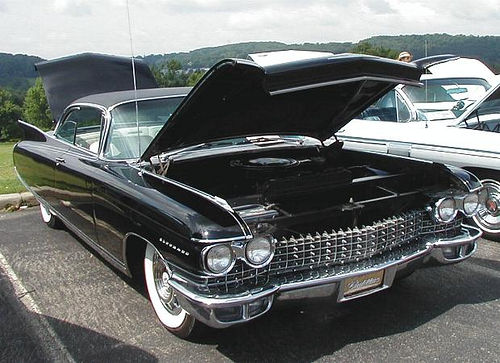Is there sufficient lighting in the image? Yes, there is sufficient lighting in the image, allowing for clear visibility of the details such as the glossy finish of the black car and the surrounding environment. 